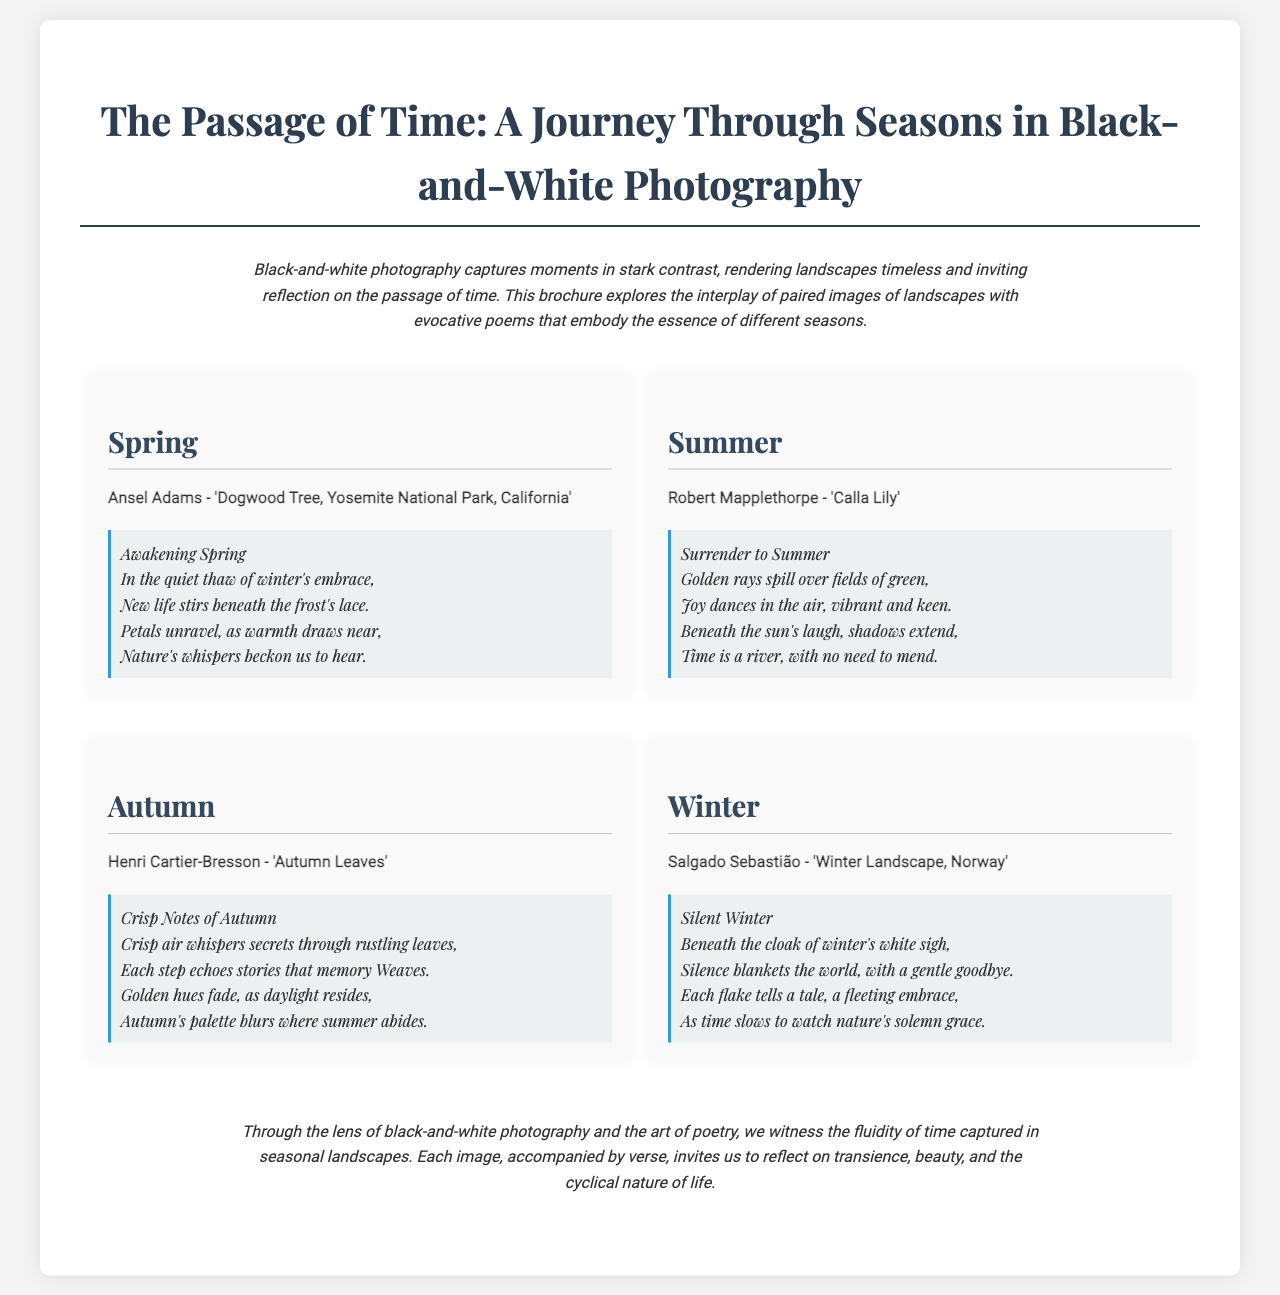What is the title of the brochure? The title is the main heading of the document, which introduces the theme and content within.
Answer: The Passage of Time: A Journey Through Seasons in Black-and-White Photography Who is the photographer of the image paired with Spring? The photographer's name is listed under the image for Spring, indicating who captured that specific photograph.
Answer: Ansel Adams What is the title of the poem associated with Winter? The title of the poem is specified right before the text, indicating the theme of the seasonal poem.
Answer: Silent Winter How many seasons are featured in the brochure? The brochure divides the content into distinct sections based on the seasons, counting each one presented.
Answer: Four What does the Summer poem emphasize about time? This aspect requires understanding the meaning conveyed in the poem related to the season of Summer.
Answer: Time is a river, with no need to mend What is the final message of the brochure? The conclusion summarizes the intent of the brochure, reflecting on the broader significance of the images and poems.
Answer: Reflect on transience, beauty, and the cyclical nature of life 